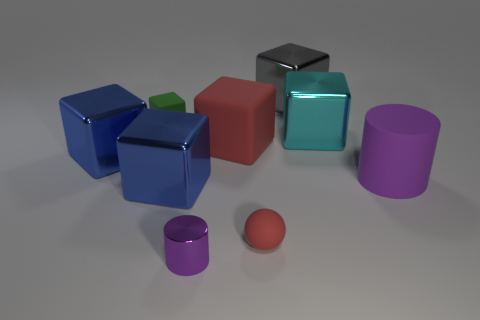The matte sphere has what color?
Give a very brief answer. Red. There is a rubber sphere; is its size the same as the purple cylinder on the right side of the red rubber ball?
Give a very brief answer. No. How many matte objects are either cyan cubes or big red things?
Your answer should be very brief. 1. Is there any other thing that is the same material as the big purple cylinder?
Ensure brevity in your answer.  Yes. Do the tiny cylinder and the large thing on the left side of the green cube have the same color?
Your response must be concise. No. What is the shape of the green rubber thing?
Ensure brevity in your answer.  Cube. There is a cylinder that is on the left side of the purple thing that is behind the small rubber object in front of the large cyan metal object; what size is it?
Keep it short and to the point. Small. What number of other objects are there of the same shape as the tiny red matte object?
Your answer should be very brief. 0. Does the small green object that is behind the large red matte object have the same shape as the purple thing behind the rubber sphere?
Give a very brief answer. No. How many cylinders are big rubber objects or big purple things?
Make the answer very short. 1. 